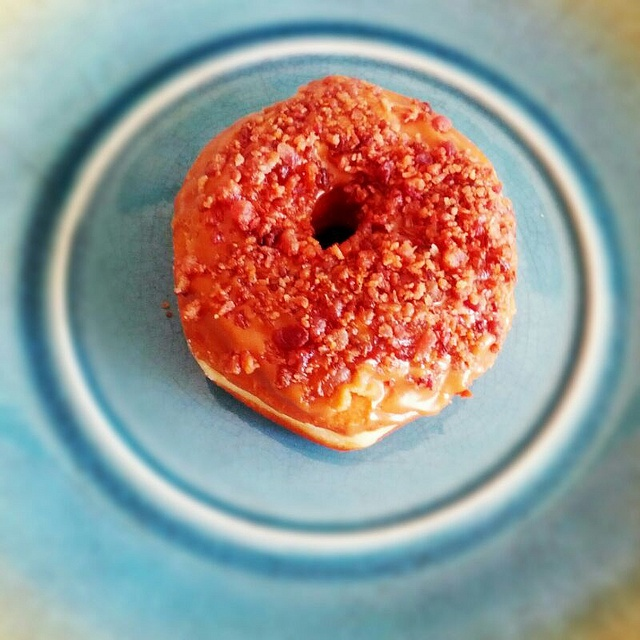Describe the objects in this image and their specific colors. I can see a donut in beige, brown, red, and salmon tones in this image. 